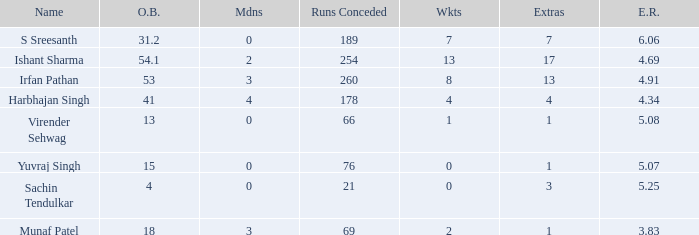Name the wickets for overs bowled being 15 0.0. 